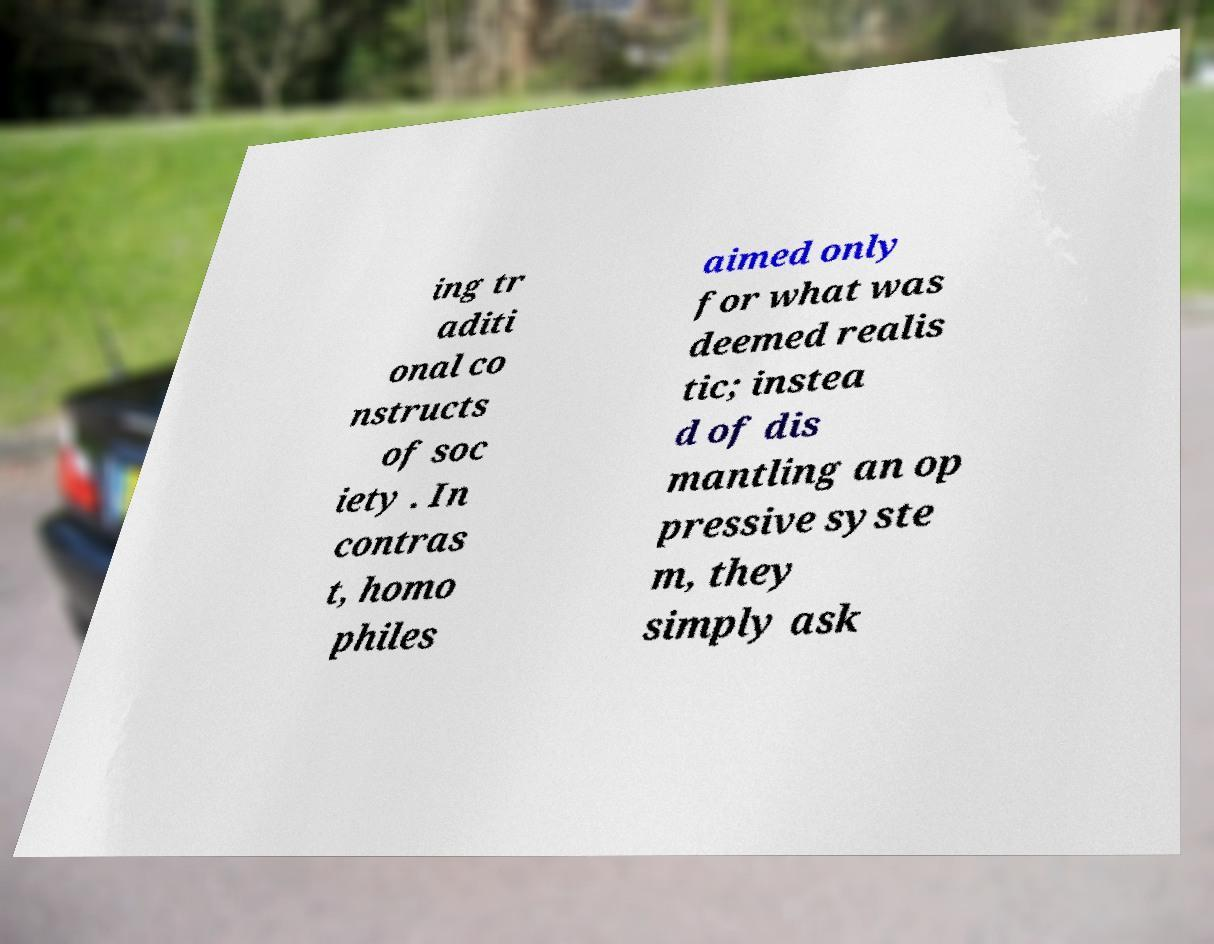Please identify and transcribe the text found in this image. ing tr aditi onal co nstructs of soc iety . In contras t, homo philes aimed only for what was deemed realis tic; instea d of dis mantling an op pressive syste m, they simply ask 